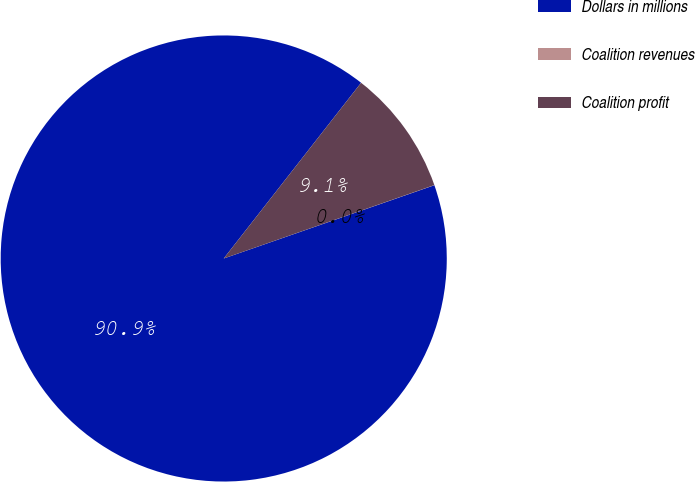Convert chart. <chart><loc_0><loc_0><loc_500><loc_500><pie_chart><fcel>Dollars in millions<fcel>Coalition revenues<fcel>Coalition profit<nl><fcel>90.89%<fcel>0.01%<fcel>9.1%<nl></chart> 